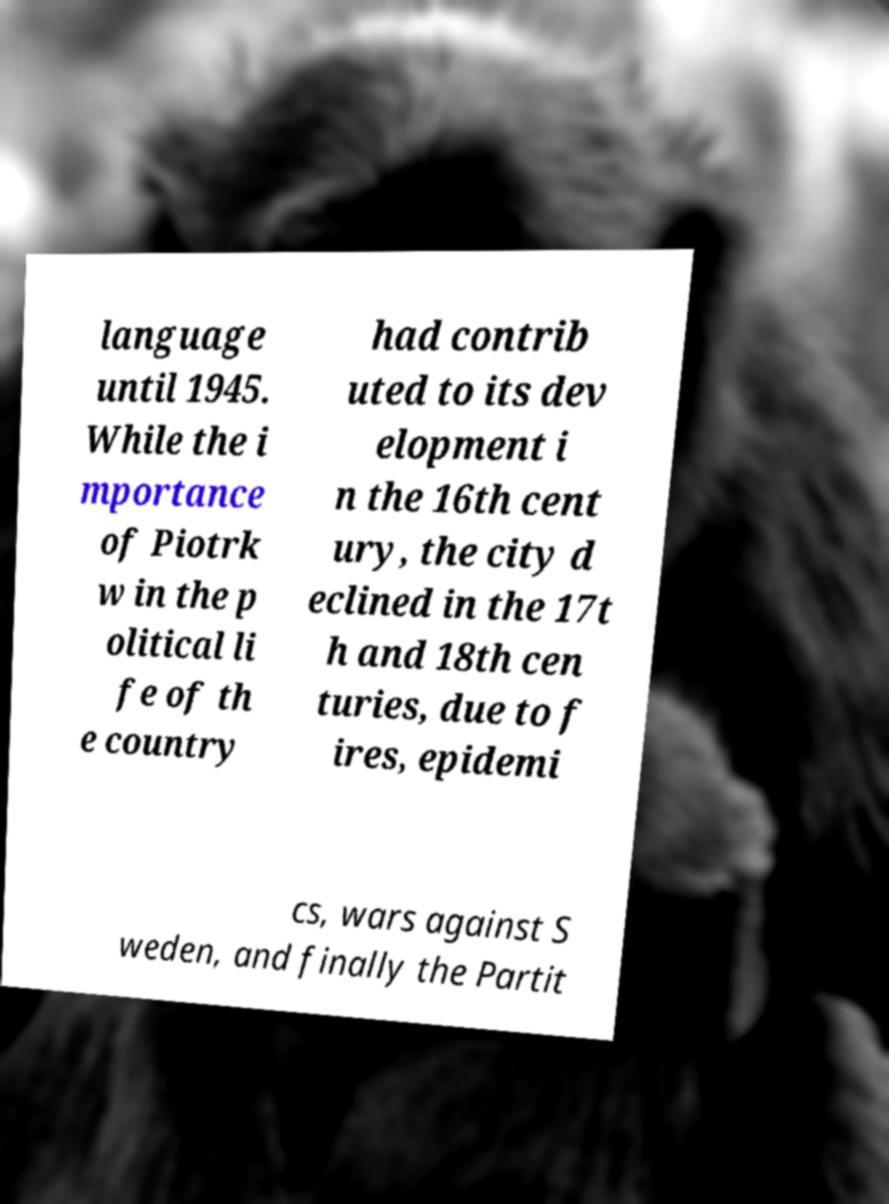Can you read and provide the text displayed in the image?This photo seems to have some interesting text. Can you extract and type it out for me? language until 1945. While the i mportance of Piotrk w in the p olitical li fe of th e country had contrib uted to its dev elopment i n the 16th cent ury, the city d eclined in the 17t h and 18th cen turies, due to f ires, epidemi cs, wars against S weden, and finally the Partit 